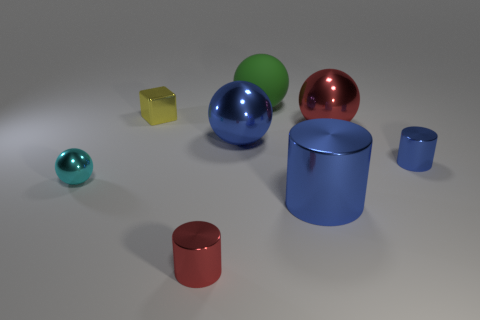Is there anything else that is the same material as the green sphere?
Provide a succinct answer. No. Is the red ball made of the same material as the large green object?
Provide a succinct answer. No. There is a metal cube that is the same size as the cyan thing; what color is it?
Ensure brevity in your answer.  Yellow. How many other objects are the same shape as the tiny cyan metallic object?
Make the answer very short. 3. Is the size of the shiny block the same as the metal cylinder that is behind the cyan metal thing?
Provide a short and direct response. Yes. How many things are either large metal cylinders or tiny cylinders?
Ensure brevity in your answer.  3. There is a large cylinder; is its color the same as the small cylinder that is right of the green matte object?
Provide a succinct answer. Yes. What number of cylinders are either big blue metal objects or large things?
Keep it short and to the point. 1. Are there any other things that have the same color as the rubber object?
Your response must be concise. No. The ball right of the large thing that is in front of the small blue metal object is made of what material?
Offer a very short reply. Metal. 